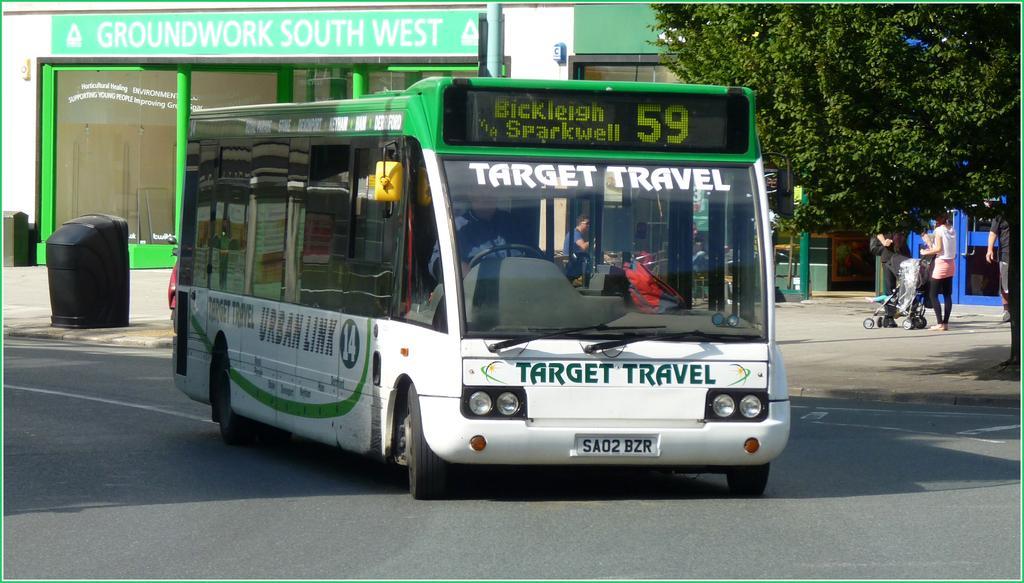How would you summarize this image in a sentence or two? In this image, we can see a bus on the road, we can see some people standing and there is a green tree. 